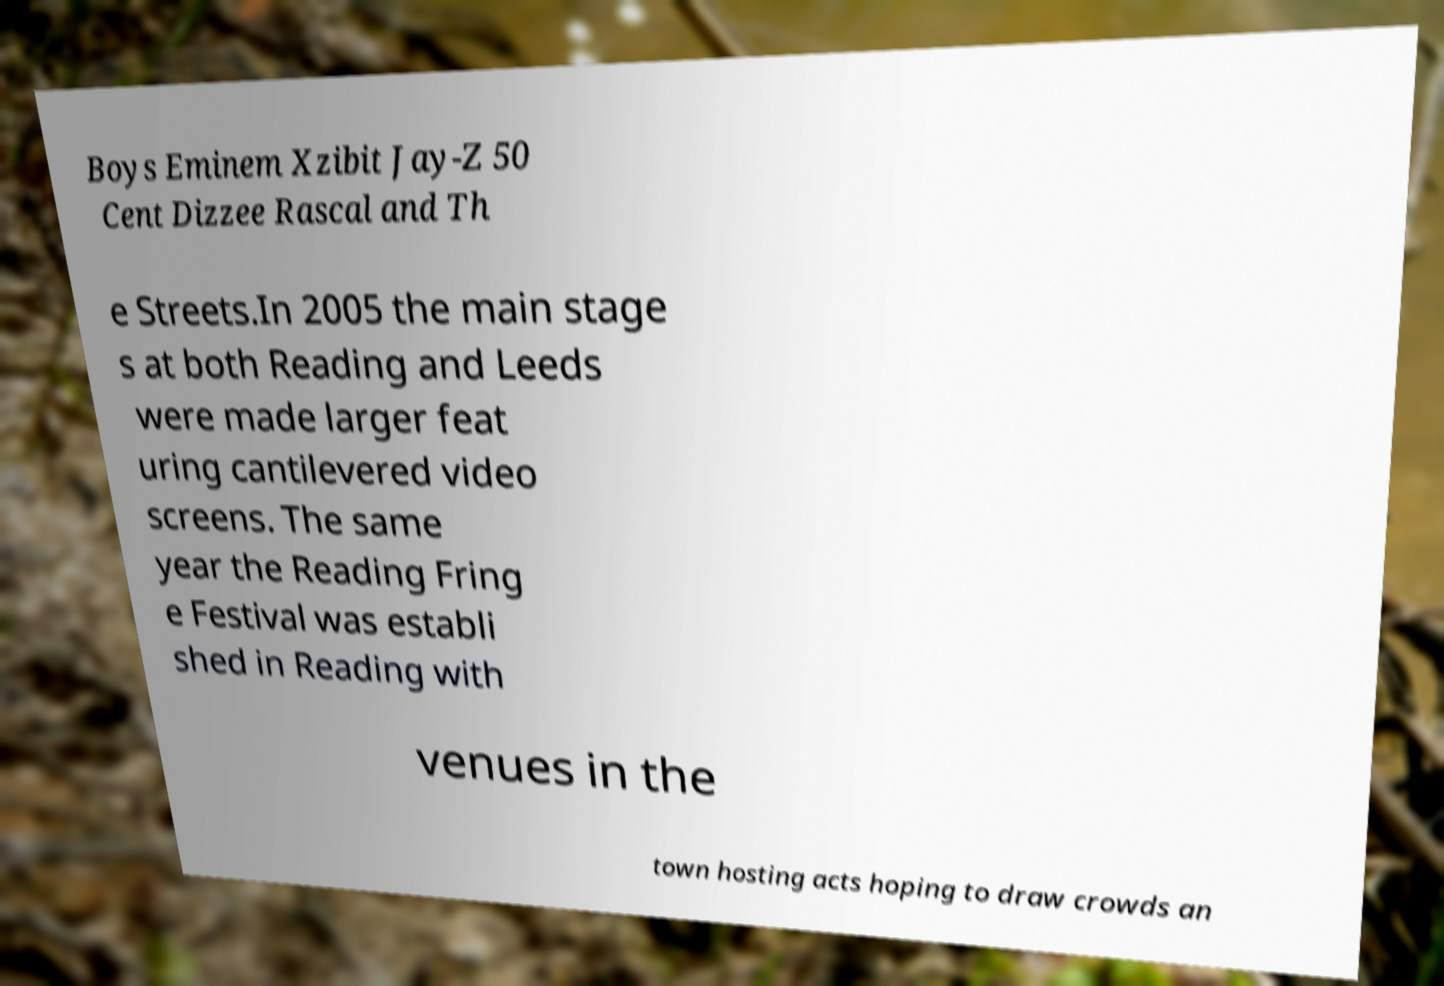Can you accurately transcribe the text from the provided image for me? Boys Eminem Xzibit Jay-Z 50 Cent Dizzee Rascal and Th e Streets.In 2005 the main stage s at both Reading and Leeds were made larger feat uring cantilevered video screens. The same year the Reading Fring e Festival was establi shed in Reading with venues in the town hosting acts hoping to draw crowds an 